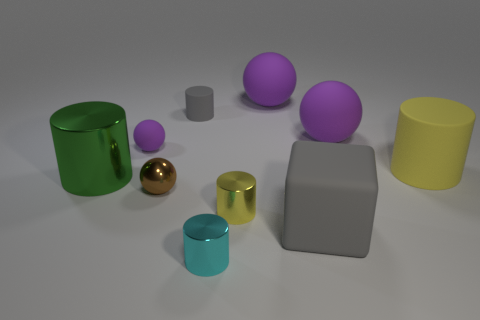What shape is the tiny thing behind the tiny purple rubber thing? cylinder 